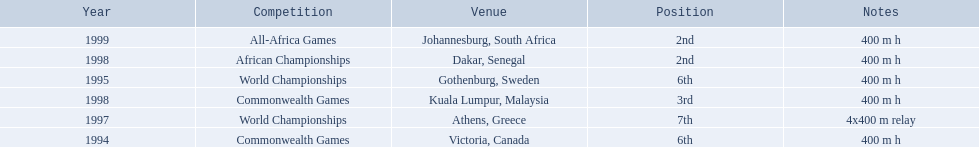What races did ken harden run? 400 m h, 400 m h, 4x400 m relay, 400 m h, 400 m h, 400 m h. Which race did ken harden run in 1997? 4x400 m relay. 